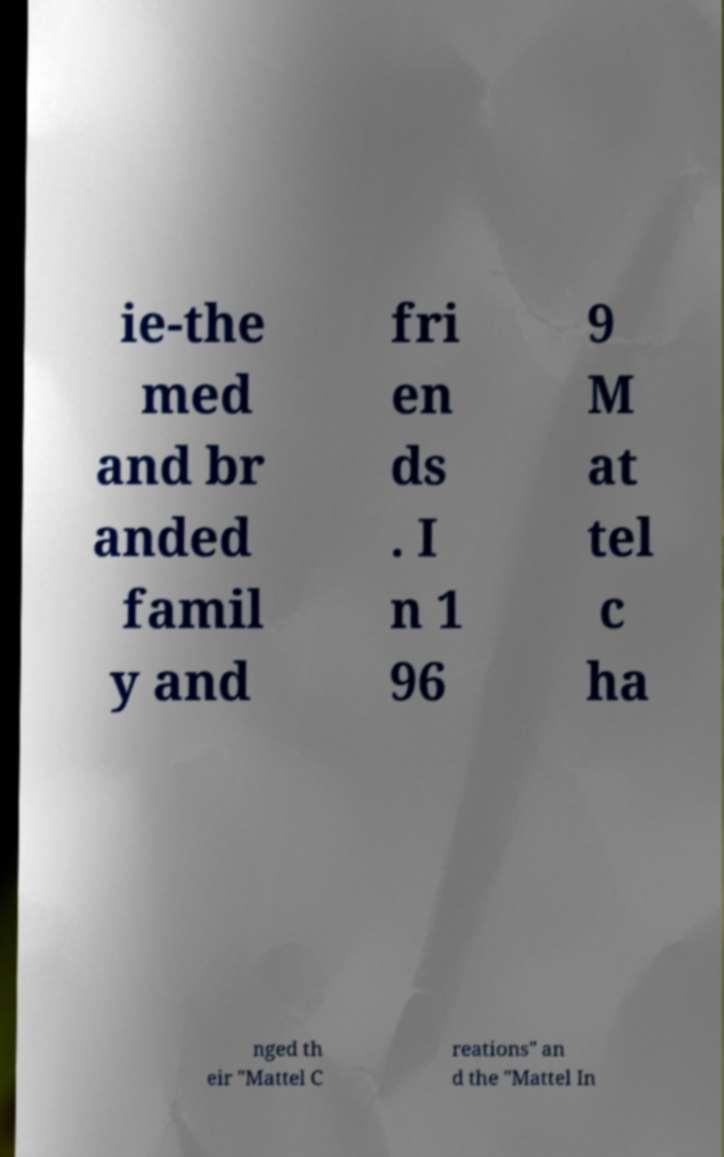Could you extract and type out the text from this image? ie-the med and br anded famil y and fri en ds . I n 1 96 9 M at tel c ha nged th eir "Mattel C reations" an d the "Mattel In 